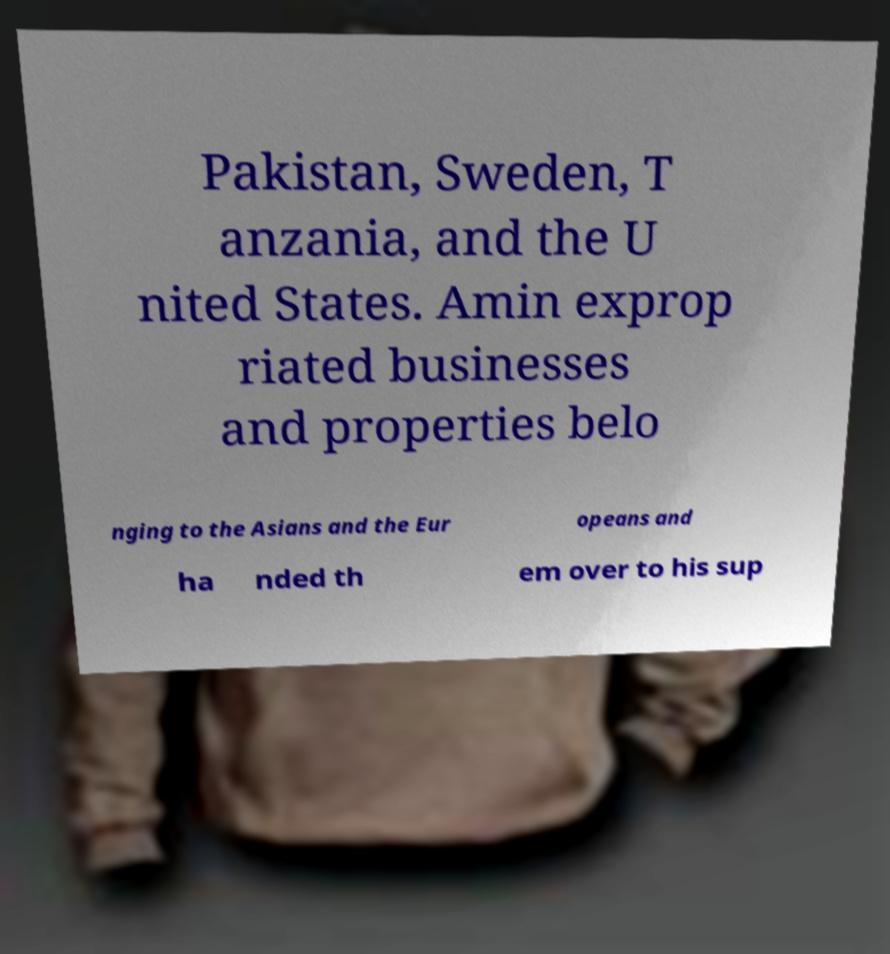Please identify and transcribe the text found in this image. Pakistan, Sweden, T anzania, and the U nited States. Amin exprop riated businesses and properties belo nging to the Asians and the Eur opeans and ha nded th em over to his sup 